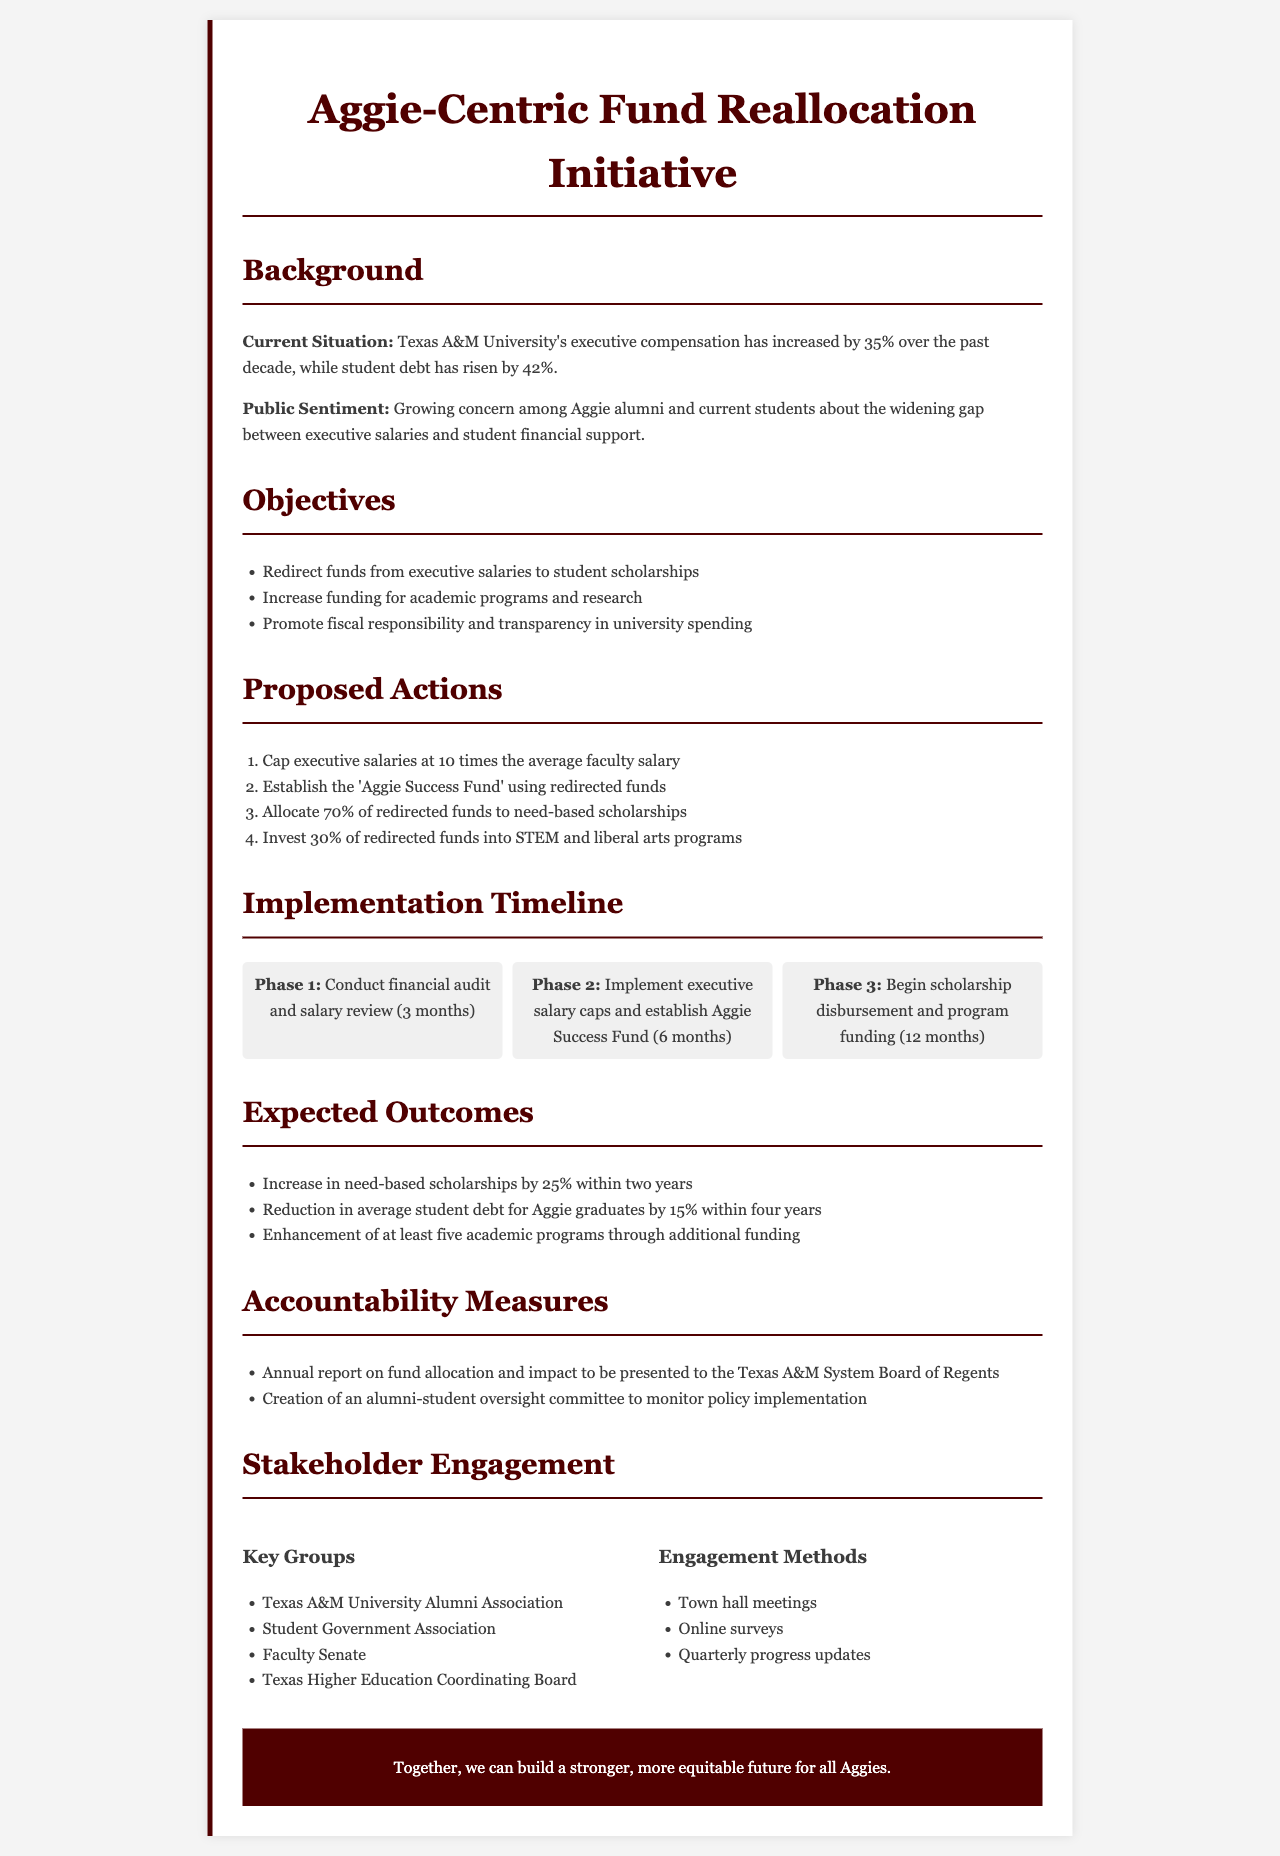What is the percentage increase in executive compensation over the past decade? The document states that Texas A&M University's executive compensation has increased by 35% over the past decade.
Answer: 35% What is the primary purpose of the Aggie Success Fund? The document indicates that funds will be redirected to establish the Aggie Success Fund for supporting scholarships and academic programs.
Answer: Scholarships and academic programs How much of the redirected funds will be allocated to need-based scholarships? According to the document, 70% of the redirected funds will be specifically allocated to need-based scholarships.
Answer: 70% What is the timeline for conducting a financial audit and salary review? The document specifies that Phase 1 involves conducting a financial audit and salary review, which will take 3 months.
Answer: 3 months What is the expected reduction in average student debt for Aggie graduates within four years? The document states that there is an expected reduction in average student debt for Aggie graduates by 15% within four years.
Answer: 15% Which stakeholder group is specifically mentioned in the engagement section? The document lists the Texas A&M University Alumni Association as one of the key groups involved in stakeholder engagement.
Answer: Texas A&M University Alumni Association What accountability measure is proposed for fund allocation reporting? The document mentions that an annual report on fund allocation and impact will be presented to the Texas A&M System Board of Regents.
Answer: Annual report What percentage of redirected funds is proposed for investment in STEM and liberal arts programs? The document states that 30% of redirected funds will be invested into STEM and liberal arts programs.
Answer: 30% What is one method mentioned for stakeholder engagement? The document lists town hall meetings as one of the methods for engaging stakeholders.
Answer: Town hall meetings 